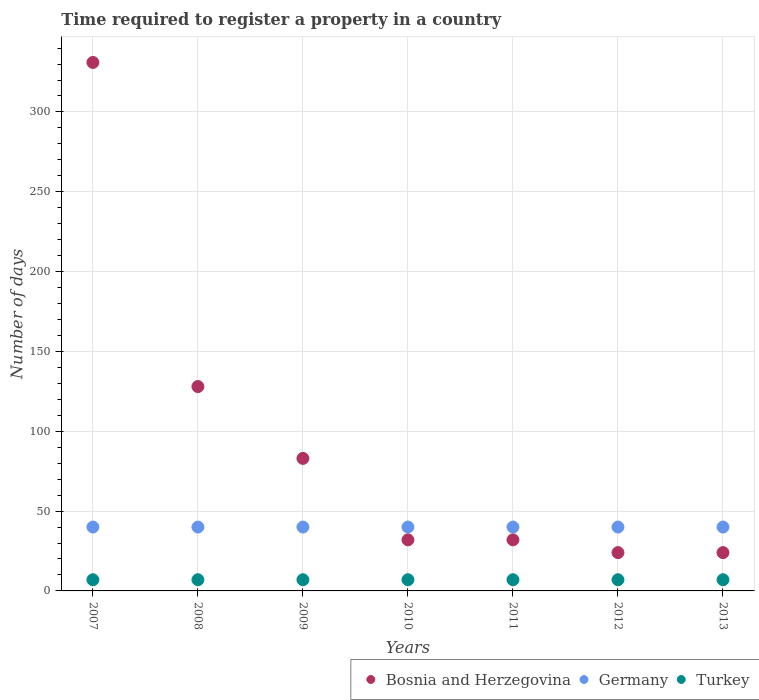What is the number of days required to register a property in Bosnia and Herzegovina in 2013?
Offer a very short reply. 24. Across all years, what is the maximum number of days required to register a property in Germany?
Ensure brevity in your answer.  40. Across all years, what is the minimum number of days required to register a property in Germany?
Your response must be concise. 40. In which year was the number of days required to register a property in Turkey minimum?
Offer a terse response. 2007. What is the total number of days required to register a property in Bosnia and Herzegovina in the graph?
Ensure brevity in your answer.  654. What is the difference between the number of days required to register a property in Turkey in 2007 and that in 2013?
Offer a very short reply. 0. What is the difference between the number of days required to register a property in Turkey in 2007 and the number of days required to register a property in Bosnia and Herzegovina in 2012?
Your answer should be compact. -17. What is the average number of days required to register a property in Turkey per year?
Make the answer very short. 7. In the year 2008, what is the difference between the number of days required to register a property in Turkey and number of days required to register a property in Bosnia and Herzegovina?
Make the answer very short. -121. In how many years, is the number of days required to register a property in Bosnia and Herzegovina greater than 170 days?
Provide a succinct answer. 1. What is the ratio of the number of days required to register a property in Germany in 2010 to that in 2012?
Your answer should be compact. 1. Is the difference between the number of days required to register a property in Turkey in 2011 and 2012 greater than the difference between the number of days required to register a property in Bosnia and Herzegovina in 2011 and 2012?
Your answer should be compact. No. In how many years, is the number of days required to register a property in Bosnia and Herzegovina greater than the average number of days required to register a property in Bosnia and Herzegovina taken over all years?
Your answer should be compact. 2. Is it the case that in every year, the sum of the number of days required to register a property in Bosnia and Herzegovina and number of days required to register a property in Germany  is greater than the number of days required to register a property in Turkey?
Provide a short and direct response. Yes. Does the number of days required to register a property in Bosnia and Herzegovina monotonically increase over the years?
Offer a very short reply. No. How many years are there in the graph?
Provide a short and direct response. 7. What is the difference between two consecutive major ticks on the Y-axis?
Make the answer very short. 50. Are the values on the major ticks of Y-axis written in scientific E-notation?
Offer a very short reply. No. Does the graph contain grids?
Your answer should be very brief. Yes. Where does the legend appear in the graph?
Offer a very short reply. Bottom right. How many legend labels are there?
Ensure brevity in your answer.  3. How are the legend labels stacked?
Keep it short and to the point. Horizontal. What is the title of the graph?
Keep it short and to the point. Time required to register a property in a country. Does "Cote d'Ivoire" appear as one of the legend labels in the graph?
Offer a terse response. No. What is the label or title of the X-axis?
Offer a very short reply. Years. What is the label or title of the Y-axis?
Your answer should be very brief. Number of days. What is the Number of days of Bosnia and Herzegovina in 2007?
Provide a succinct answer. 331. What is the Number of days of Bosnia and Herzegovina in 2008?
Make the answer very short. 128. What is the Number of days of Bosnia and Herzegovina in 2009?
Offer a very short reply. 83. What is the Number of days of Bosnia and Herzegovina in 2010?
Your answer should be very brief. 32. What is the Number of days of Bosnia and Herzegovina in 2011?
Your answer should be very brief. 32. What is the Number of days of Germany in 2011?
Offer a very short reply. 40. What is the Number of days of Turkey in 2011?
Your answer should be very brief. 7. What is the Number of days of Germany in 2012?
Make the answer very short. 40. What is the Number of days in Turkey in 2012?
Keep it short and to the point. 7. What is the Number of days in Germany in 2013?
Your answer should be very brief. 40. Across all years, what is the maximum Number of days in Bosnia and Herzegovina?
Make the answer very short. 331. Across all years, what is the maximum Number of days of Germany?
Offer a very short reply. 40. Across all years, what is the maximum Number of days of Turkey?
Keep it short and to the point. 7. Across all years, what is the minimum Number of days in Germany?
Provide a succinct answer. 40. What is the total Number of days of Bosnia and Herzegovina in the graph?
Your response must be concise. 654. What is the total Number of days in Germany in the graph?
Offer a very short reply. 280. What is the total Number of days of Turkey in the graph?
Your response must be concise. 49. What is the difference between the Number of days of Bosnia and Herzegovina in 2007 and that in 2008?
Your answer should be very brief. 203. What is the difference between the Number of days in Germany in 2007 and that in 2008?
Your response must be concise. 0. What is the difference between the Number of days of Bosnia and Herzegovina in 2007 and that in 2009?
Your answer should be compact. 248. What is the difference between the Number of days of Germany in 2007 and that in 2009?
Provide a short and direct response. 0. What is the difference between the Number of days of Turkey in 2007 and that in 2009?
Ensure brevity in your answer.  0. What is the difference between the Number of days in Bosnia and Herzegovina in 2007 and that in 2010?
Your answer should be compact. 299. What is the difference between the Number of days of Bosnia and Herzegovina in 2007 and that in 2011?
Your answer should be compact. 299. What is the difference between the Number of days in Germany in 2007 and that in 2011?
Your answer should be compact. 0. What is the difference between the Number of days in Bosnia and Herzegovina in 2007 and that in 2012?
Ensure brevity in your answer.  307. What is the difference between the Number of days in Germany in 2007 and that in 2012?
Your response must be concise. 0. What is the difference between the Number of days in Turkey in 2007 and that in 2012?
Your response must be concise. 0. What is the difference between the Number of days in Bosnia and Herzegovina in 2007 and that in 2013?
Provide a short and direct response. 307. What is the difference between the Number of days of Bosnia and Herzegovina in 2008 and that in 2009?
Keep it short and to the point. 45. What is the difference between the Number of days in Bosnia and Herzegovina in 2008 and that in 2010?
Your response must be concise. 96. What is the difference between the Number of days in Bosnia and Herzegovina in 2008 and that in 2011?
Offer a very short reply. 96. What is the difference between the Number of days of Bosnia and Herzegovina in 2008 and that in 2012?
Your response must be concise. 104. What is the difference between the Number of days in Germany in 2008 and that in 2012?
Your response must be concise. 0. What is the difference between the Number of days of Turkey in 2008 and that in 2012?
Your response must be concise. 0. What is the difference between the Number of days of Bosnia and Herzegovina in 2008 and that in 2013?
Your answer should be compact. 104. What is the difference between the Number of days of Turkey in 2008 and that in 2013?
Your response must be concise. 0. What is the difference between the Number of days of Bosnia and Herzegovina in 2009 and that in 2010?
Your response must be concise. 51. What is the difference between the Number of days of Germany in 2009 and that in 2010?
Provide a short and direct response. 0. What is the difference between the Number of days in Germany in 2009 and that in 2012?
Ensure brevity in your answer.  0. What is the difference between the Number of days of Turkey in 2009 and that in 2012?
Ensure brevity in your answer.  0. What is the difference between the Number of days in Bosnia and Herzegovina in 2009 and that in 2013?
Your response must be concise. 59. What is the difference between the Number of days in Turkey in 2009 and that in 2013?
Offer a very short reply. 0. What is the difference between the Number of days of Germany in 2010 and that in 2011?
Provide a short and direct response. 0. What is the difference between the Number of days of Turkey in 2010 and that in 2011?
Provide a short and direct response. 0. What is the difference between the Number of days in Bosnia and Herzegovina in 2010 and that in 2013?
Offer a very short reply. 8. What is the difference between the Number of days in Germany in 2010 and that in 2013?
Make the answer very short. 0. What is the difference between the Number of days of Turkey in 2010 and that in 2013?
Provide a short and direct response. 0. What is the difference between the Number of days in Bosnia and Herzegovina in 2011 and that in 2012?
Your answer should be very brief. 8. What is the difference between the Number of days in Germany in 2011 and that in 2012?
Keep it short and to the point. 0. What is the difference between the Number of days of Bosnia and Herzegovina in 2011 and that in 2013?
Offer a terse response. 8. What is the difference between the Number of days in Turkey in 2011 and that in 2013?
Give a very brief answer. 0. What is the difference between the Number of days of Bosnia and Herzegovina in 2012 and that in 2013?
Keep it short and to the point. 0. What is the difference between the Number of days in Germany in 2012 and that in 2013?
Make the answer very short. 0. What is the difference between the Number of days of Turkey in 2012 and that in 2013?
Make the answer very short. 0. What is the difference between the Number of days of Bosnia and Herzegovina in 2007 and the Number of days of Germany in 2008?
Your answer should be compact. 291. What is the difference between the Number of days of Bosnia and Herzegovina in 2007 and the Number of days of Turkey in 2008?
Provide a short and direct response. 324. What is the difference between the Number of days in Germany in 2007 and the Number of days in Turkey in 2008?
Make the answer very short. 33. What is the difference between the Number of days in Bosnia and Herzegovina in 2007 and the Number of days in Germany in 2009?
Your answer should be very brief. 291. What is the difference between the Number of days of Bosnia and Herzegovina in 2007 and the Number of days of Turkey in 2009?
Ensure brevity in your answer.  324. What is the difference between the Number of days in Germany in 2007 and the Number of days in Turkey in 2009?
Offer a terse response. 33. What is the difference between the Number of days of Bosnia and Herzegovina in 2007 and the Number of days of Germany in 2010?
Your answer should be very brief. 291. What is the difference between the Number of days in Bosnia and Herzegovina in 2007 and the Number of days in Turkey in 2010?
Keep it short and to the point. 324. What is the difference between the Number of days in Germany in 2007 and the Number of days in Turkey in 2010?
Provide a succinct answer. 33. What is the difference between the Number of days in Bosnia and Herzegovina in 2007 and the Number of days in Germany in 2011?
Your answer should be compact. 291. What is the difference between the Number of days in Bosnia and Herzegovina in 2007 and the Number of days in Turkey in 2011?
Your response must be concise. 324. What is the difference between the Number of days of Bosnia and Herzegovina in 2007 and the Number of days of Germany in 2012?
Give a very brief answer. 291. What is the difference between the Number of days in Bosnia and Herzegovina in 2007 and the Number of days in Turkey in 2012?
Offer a very short reply. 324. What is the difference between the Number of days in Germany in 2007 and the Number of days in Turkey in 2012?
Your response must be concise. 33. What is the difference between the Number of days in Bosnia and Herzegovina in 2007 and the Number of days in Germany in 2013?
Offer a terse response. 291. What is the difference between the Number of days in Bosnia and Herzegovina in 2007 and the Number of days in Turkey in 2013?
Your answer should be very brief. 324. What is the difference between the Number of days in Bosnia and Herzegovina in 2008 and the Number of days in Germany in 2009?
Provide a short and direct response. 88. What is the difference between the Number of days of Bosnia and Herzegovina in 2008 and the Number of days of Turkey in 2009?
Keep it short and to the point. 121. What is the difference between the Number of days of Bosnia and Herzegovina in 2008 and the Number of days of Turkey in 2010?
Your answer should be very brief. 121. What is the difference between the Number of days in Germany in 2008 and the Number of days in Turkey in 2010?
Your answer should be compact. 33. What is the difference between the Number of days in Bosnia and Herzegovina in 2008 and the Number of days in Turkey in 2011?
Make the answer very short. 121. What is the difference between the Number of days in Germany in 2008 and the Number of days in Turkey in 2011?
Provide a short and direct response. 33. What is the difference between the Number of days of Bosnia and Herzegovina in 2008 and the Number of days of Turkey in 2012?
Offer a very short reply. 121. What is the difference between the Number of days in Germany in 2008 and the Number of days in Turkey in 2012?
Provide a succinct answer. 33. What is the difference between the Number of days in Bosnia and Herzegovina in 2008 and the Number of days in Germany in 2013?
Your answer should be compact. 88. What is the difference between the Number of days in Bosnia and Herzegovina in 2008 and the Number of days in Turkey in 2013?
Offer a terse response. 121. What is the difference between the Number of days in Bosnia and Herzegovina in 2009 and the Number of days in Turkey in 2010?
Ensure brevity in your answer.  76. What is the difference between the Number of days of Germany in 2009 and the Number of days of Turkey in 2010?
Your response must be concise. 33. What is the difference between the Number of days in Bosnia and Herzegovina in 2009 and the Number of days in Germany in 2011?
Your answer should be compact. 43. What is the difference between the Number of days in Germany in 2009 and the Number of days in Turkey in 2011?
Keep it short and to the point. 33. What is the difference between the Number of days of Bosnia and Herzegovina in 2009 and the Number of days of Germany in 2013?
Provide a succinct answer. 43. What is the difference between the Number of days in Bosnia and Herzegovina in 2009 and the Number of days in Turkey in 2013?
Provide a short and direct response. 76. What is the difference between the Number of days of Bosnia and Herzegovina in 2010 and the Number of days of Germany in 2012?
Offer a terse response. -8. What is the difference between the Number of days in Germany in 2010 and the Number of days in Turkey in 2012?
Offer a very short reply. 33. What is the difference between the Number of days of Bosnia and Herzegovina in 2011 and the Number of days of Germany in 2012?
Your answer should be very brief. -8. What is the difference between the Number of days of Bosnia and Herzegovina in 2011 and the Number of days of Turkey in 2012?
Make the answer very short. 25. What is the difference between the Number of days in Bosnia and Herzegovina in 2011 and the Number of days in Germany in 2013?
Provide a short and direct response. -8. What is the difference between the Number of days of Germany in 2011 and the Number of days of Turkey in 2013?
Offer a terse response. 33. What is the difference between the Number of days in Bosnia and Herzegovina in 2012 and the Number of days in Germany in 2013?
Provide a succinct answer. -16. What is the difference between the Number of days of Germany in 2012 and the Number of days of Turkey in 2013?
Provide a short and direct response. 33. What is the average Number of days of Bosnia and Herzegovina per year?
Your answer should be compact. 93.43. What is the average Number of days in Turkey per year?
Give a very brief answer. 7. In the year 2007, what is the difference between the Number of days in Bosnia and Herzegovina and Number of days in Germany?
Ensure brevity in your answer.  291. In the year 2007, what is the difference between the Number of days in Bosnia and Herzegovina and Number of days in Turkey?
Ensure brevity in your answer.  324. In the year 2007, what is the difference between the Number of days of Germany and Number of days of Turkey?
Offer a terse response. 33. In the year 2008, what is the difference between the Number of days of Bosnia and Herzegovina and Number of days of Germany?
Your response must be concise. 88. In the year 2008, what is the difference between the Number of days in Bosnia and Herzegovina and Number of days in Turkey?
Your response must be concise. 121. In the year 2008, what is the difference between the Number of days in Germany and Number of days in Turkey?
Keep it short and to the point. 33. In the year 2009, what is the difference between the Number of days in Germany and Number of days in Turkey?
Offer a terse response. 33. In the year 2010, what is the difference between the Number of days of Bosnia and Herzegovina and Number of days of Germany?
Offer a very short reply. -8. In the year 2010, what is the difference between the Number of days in Bosnia and Herzegovina and Number of days in Turkey?
Ensure brevity in your answer.  25. In the year 2011, what is the difference between the Number of days in Bosnia and Herzegovina and Number of days in Turkey?
Give a very brief answer. 25. In the year 2012, what is the difference between the Number of days of Bosnia and Herzegovina and Number of days of Turkey?
Your answer should be very brief. 17. In the year 2012, what is the difference between the Number of days of Germany and Number of days of Turkey?
Provide a succinct answer. 33. In the year 2013, what is the difference between the Number of days in Germany and Number of days in Turkey?
Give a very brief answer. 33. What is the ratio of the Number of days of Bosnia and Herzegovina in 2007 to that in 2008?
Your answer should be compact. 2.59. What is the ratio of the Number of days of Turkey in 2007 to that in 2008?
Your response must be concise. 1. What is the ratio of the Number of days in Bosnia and Herzegovina in 2007 to that in 2009?
Your response must be concise. 3.99. What is the ratio of the Number of days of Germany in 2007 to that in 2009?
Make the answer very short. 1. What is the ratio of the Number of days of Bosnia and Herzegovina in 2007 to that in 2010?
Make the answer very short. 10.34. What is the ratio of the Number of days in Bosnia and Herzegovina in 2007 to that in 2011?
Make the answer very short. 10.34. What is the ratio of the Number of days in Turkey in 2007 to that in 2011?
Your answer should be very brief. 1. What is the ratio of the Number of days in Bosnia and Herzegovina in 2007 to that in 2012?
Your answer should be very brief. 13.79. What is the ratio of the Number of days in Bosnia and Herzegovina in 2007 to that in 2013?
Make the answer very short. 13.79. What is the ratio of the Number of days in Turkey in 2007 to that in 2013?
Your answer should be very brief. 1. What is the ratio of the Number of days in Bosnia and Herzegovina in 2008 to that in 2009?
Your response must be concise. 1.54. What is the ratio of the Number of days of Germany in 2008 to that in 2009?
Offer a very short reply. 1. What is the ratio of the Number of days in Germany in 2008 to that in 2010?
Your response must be concise. 1. What is the ratio of the Number of days in Turkey in 2008 to that in 2010?
Your response must be concise. 1. What is the ratio of the Number of days in Germany in 2008 to that in 2011?
Make the answer very short. 1. What is the ratio of the Number of days of Turkey in 2008 to that in 2011?
Your answer should be very brief. 1. What is the ratio of the Number of days of Bosnia and Herzegovina in 2008 to that in 2012?
Provide a short and direct response. 5.33. What is the ratio of the Number of days of Bosnia and Herzegovina in 2008 to that in 2013?
Ensure brevity in your answer.  5.33. What is the ratio of the Number of days in Germany in 2008 to that in 2013?
Provide a short and direct response. 1. What is the ratio of the Number of days in Bosnia and Herzegovina in 2009 to that in 2010?
Your response must be concise. 2.59. What is the ratio of the Number of days of Germany in 2009 to that in 2010?
Provide a succinct answer. 1. What is the ratio of the Number of days in Bosnia and Herzegovina in 2009 to that in 2011?
Ensure brevity in your answer.  2.59. What is the ratio of the Number of days of Germany in 2009 to that in 2011?
Make the answer very short. 1. What is the ratio of the Number of days of Turkey in 2009 to that in 2011?
Offer a terse response. 1. What is the ratio of the Number of days in Bosnia and Herzegovina in 2009 to that in 2012?
Your answer should be compact. 3.46. What is the ratio of the Number of days in Bosnia and Herzegovina in 2009 to that in 2013?
Your answer should be very brief. 3.46. What is the ratio of the Number of days of Turkey in 2009 to that in 2013?
Make the answer very short. 1. What is the ratio of the Number of days in Bosnia and Herzegovina in 2010 to that in 2011?
Offer a very short reply. 1. What is the ratio of the Number of days in Bosnia and Herzegovina in 2010 to that in 2012?
Keep it short and to the point. 1.33. What is the ratio of the Number of days of Germany in 2010 to that in 2013?
Your answer should be very brief. 1. What is the ratio of the Number of days in Bosnia and Herzegovina in 2011 to that in 2012?
Give a very brief answer. 1.33. What is the ratio of the Number of days of Turkey in 2011 to that in 2012?
Offer a very short reply. 1. What is the ratio of the Number of days in Bosnia and Herzegovina in 2011 to that in 2013?
Ensure brevity in your answer.  1.33. What is the ratio of the Number of days in Germany in 2012 to that in 2013?
Give a very brief answer. 1. What is the ratio of the Number of days in Turkey in 2012 to that in 2013?
Your response must be concise. 1. What is the difference between the highest and the second highest Number of days in Bosnia and Herzegovina?
Give a very brief answer. 203. What is the difference between the highest and the second highest Number of days in Germany?
Make the answer very short. 0. What is the difference between the highest and the lowest Number of days in Bosnia and Herzegovina?
Your answer should be compact. 307. What is the difference between the highest and the lowest Number of days in Turkey?
Offer a terse response. 0. 